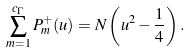<formula> <loc_0><loc_0><loc_500><loc_500>\sum _ { m = 1 } ^ { c _ { \Gamma } } P _ { m } ^ { + } ( u ) = N \left ( u ^ { 2 } - \frac { 1 } { 4 } \right ) .</formula> 